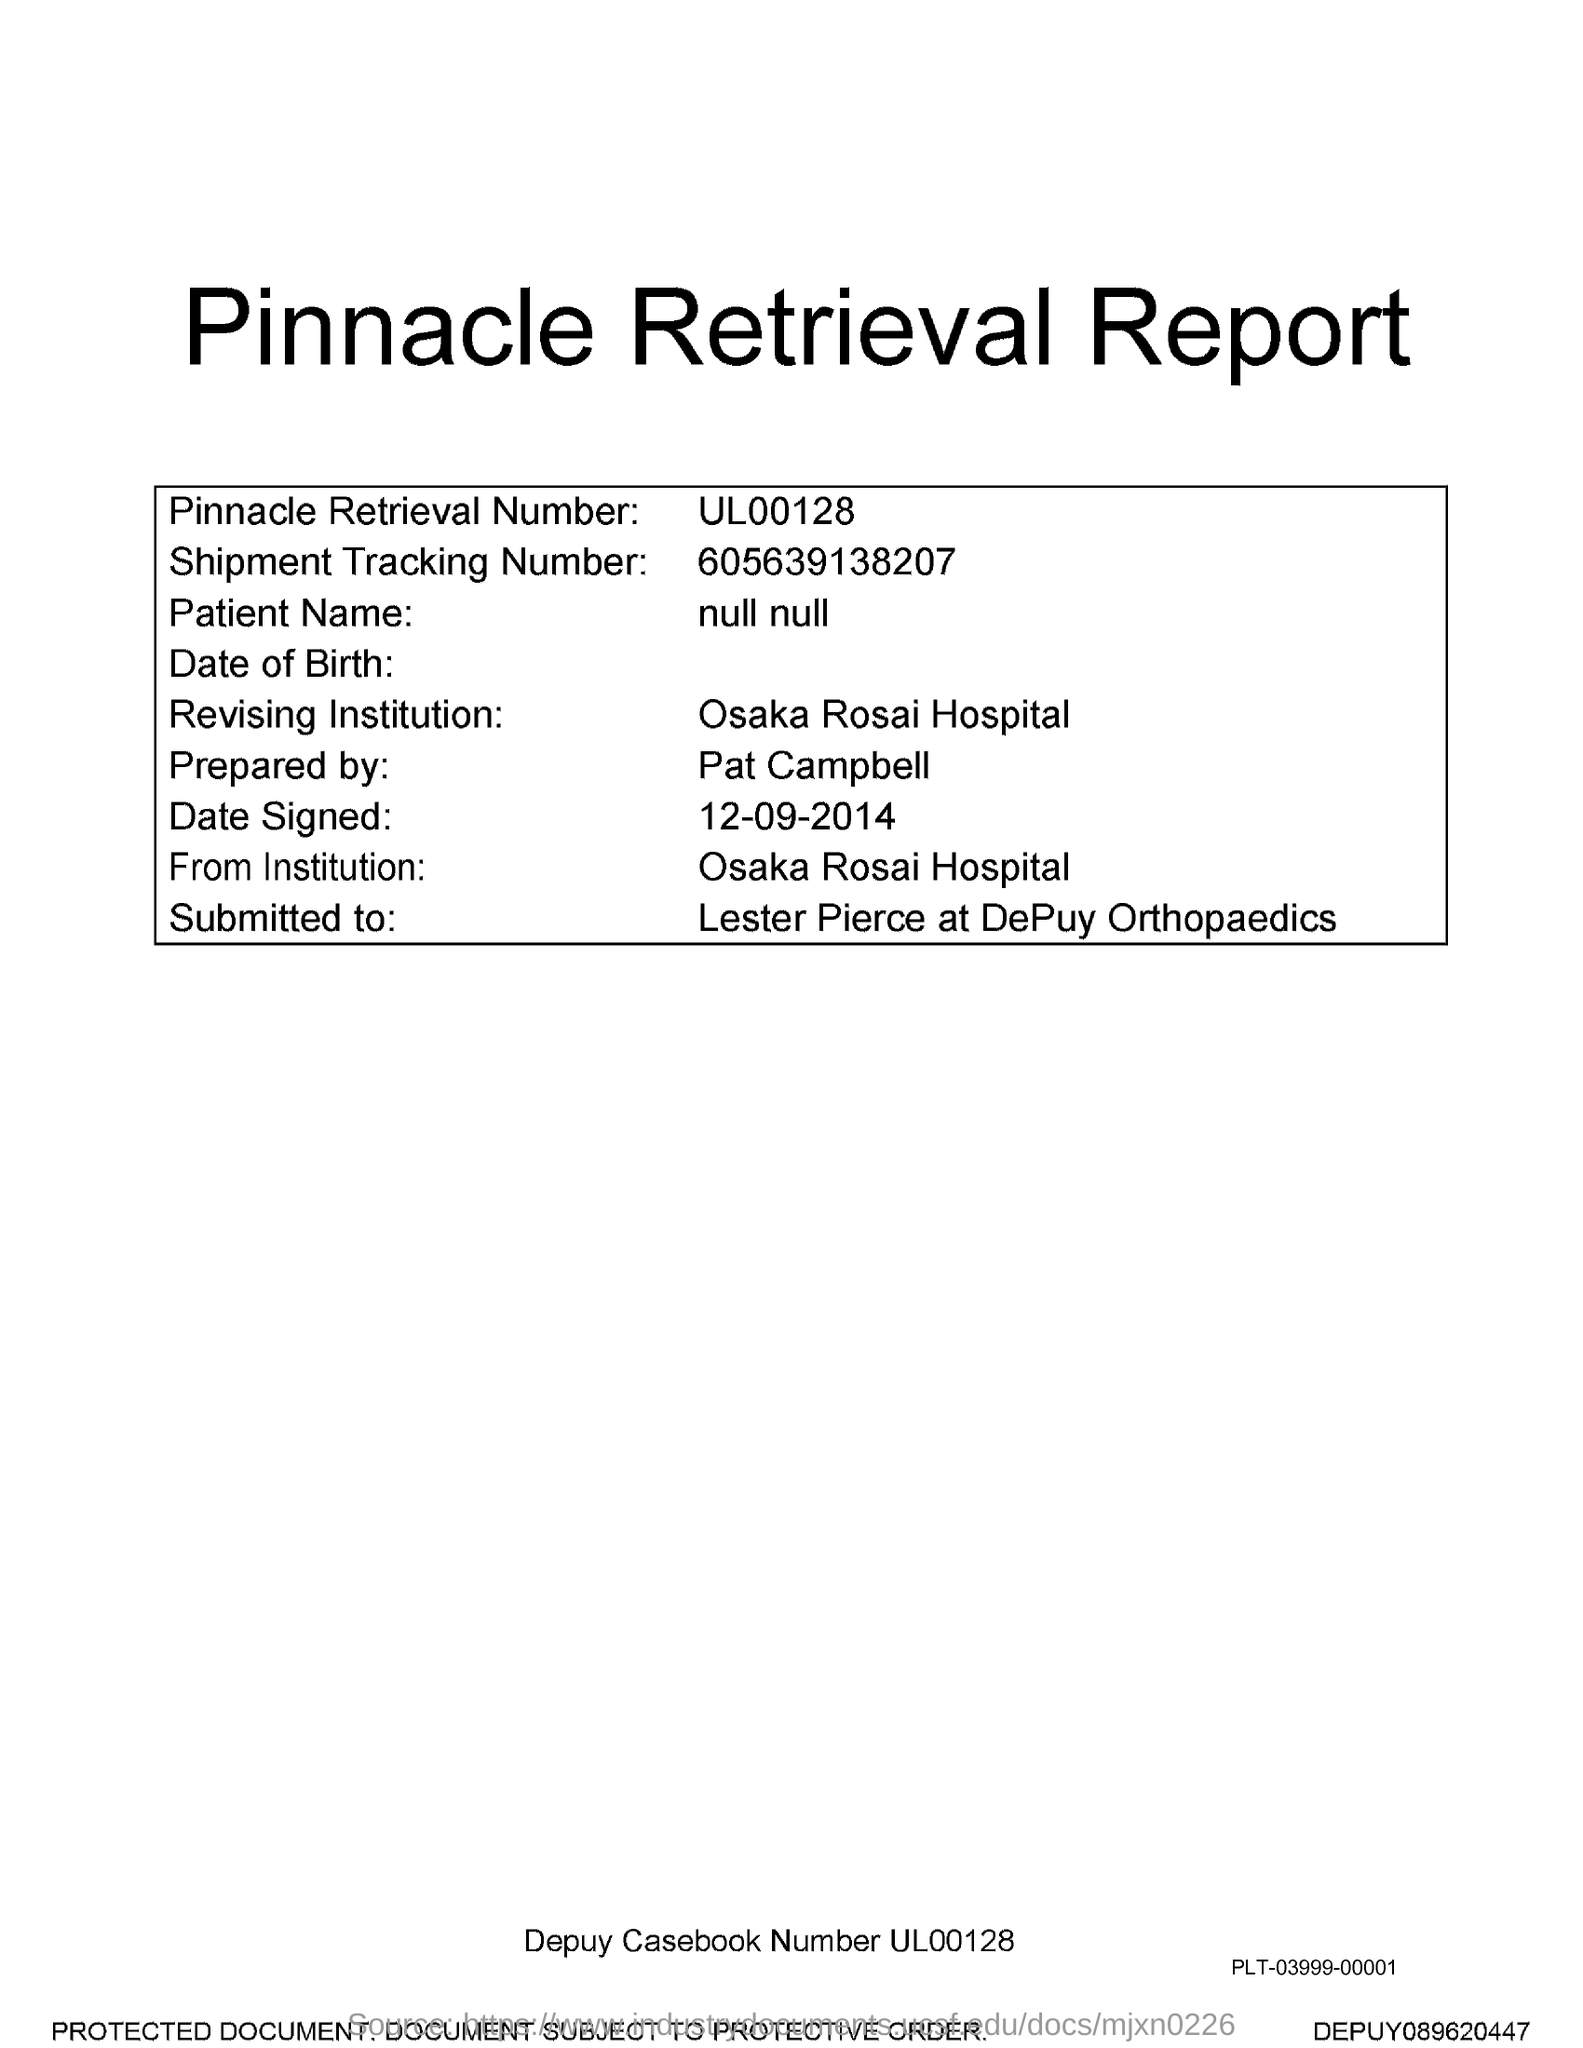What is the title of the document?
Offer a terse response. Pinnacle Retrieval Report. What is the Pinnacle Retrieval Number?
Give a very brief answer. UL00128. What is the Shipment Tracking Number?
Your answer should be compact. 605639138207. 